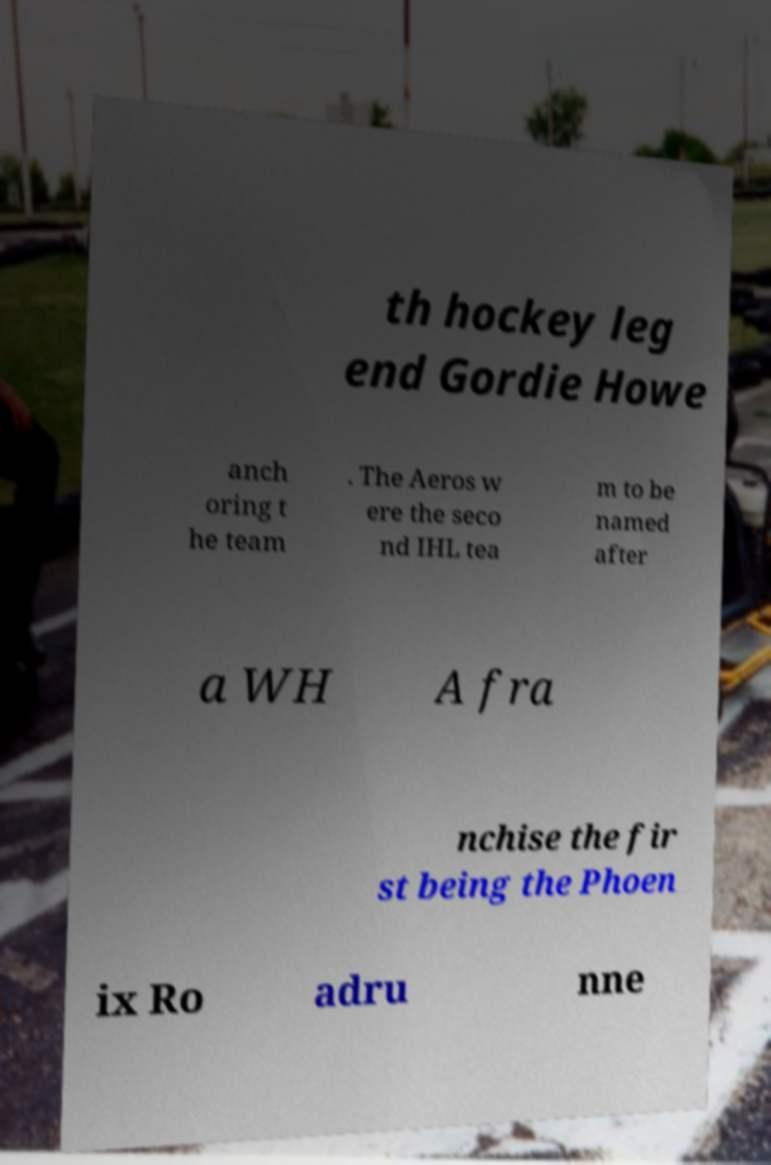Can you accurately transcribe the text from the provided image for me? th hockey leg end Gordie Howe anch oring t he team . The Aeros w ere the seco nd IHL tea m to be named after a WH A fra nchise the fir st being the Phoen ix Ro adru nne 